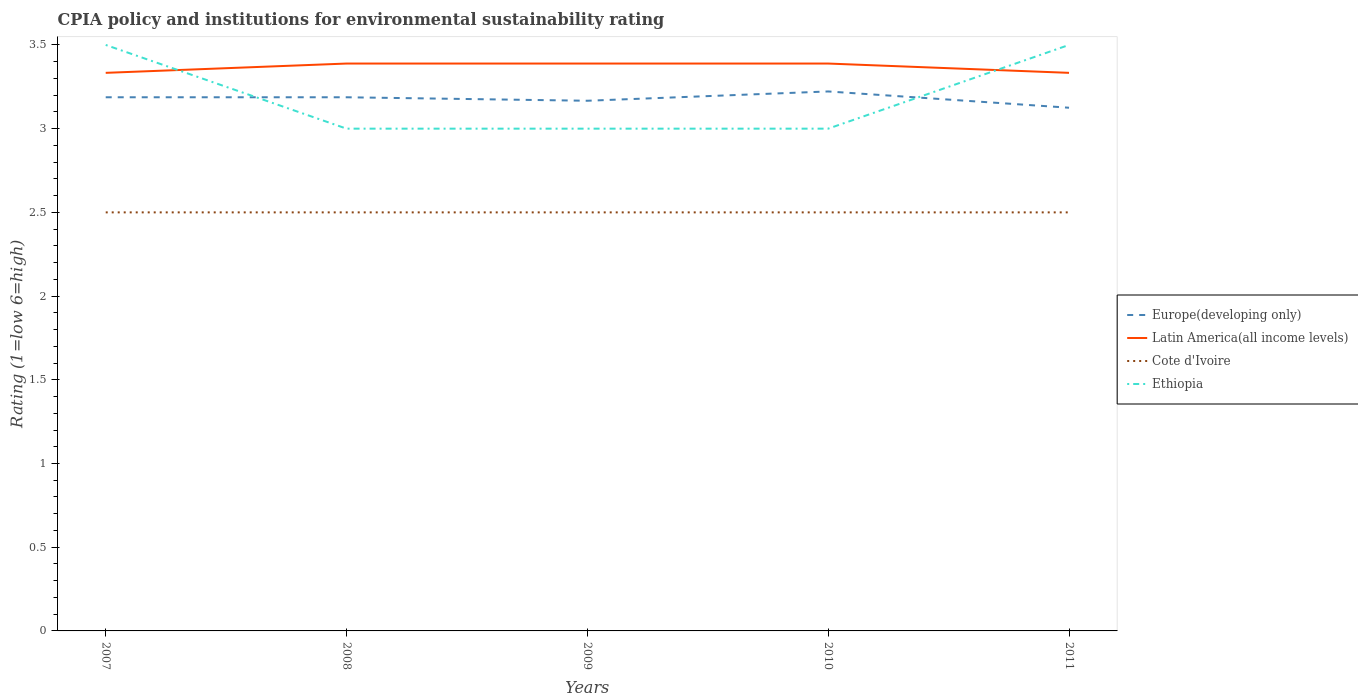How many different coloured lines are there?
Provide a short and direct response. 4. What is the total CPIA rating in Ethiopia in the graph?
Offer a terse response. 0. What is the difference between the highest and the second highest CPIA rating in Europe(developing only)?
Provide a short and direct response. 0.1. Are the values on the major ticks of Y-axis written in scientific E-notation?
Keep it short and to the point. No. Does the graph contain any zero values?
Your answer should be compact. No. Does the graph contain grids?
Make the answer very short. No. How many legend labels are there?
Keep it short and to the point. 4. How are the legend labels stacked?
Give a very brief answer. Vertical. What is the title of the graph?
Offer a terse response. CPIA policy and institutions for environmental sustainability rating. Does "Bahamas" appear as one of the legend labels in the graph?
Make the answer very short. No. What is the label or title of the X-axis?
Your answer should be compact. Years. What is the Rating (1=low 6=high) of Europe(developing only) in 2007?
Your response must be concise. 3.19. What is the Rating (1=low 6=high) of Latin America(all income levels) in 2007?
Offer a very short reply. 3.33. What is the Rating (1=low 6=high) in Ethiopia in 2007?
Ensure brevity in your answer.  3.5. What is the Rating (1=low 6=high) of Europe(developing only) in 2008?
Keep it short and to the point. 3.19. What is the Rating (1=low 6=high) of Latin America(all income levels) in 2008?
Give a very brief answer. 3.39. What is the Rating (1=low 6=high) of Cote d'Ivoire in 2008?
Keep it short and to the point. 2.5. What is the Rating (1=low 6=high) in Europe(developing only) in 2009?
Your answer should be very brief. 3.17. What is the Rating (1=low 6=high) in Latin America(all income levels) in 2009?
Provide a short and direct response. 3.39. What is the Rating (1=low 6=high) in Europe(developing only) in 2010?
Offer a very short reply. 3.22. What is the Rating (1=low 6=high) in Latin America(all income levels) in 2010?
Keep it short and to the point. 3.39. What is the Rating (1=low 6=high) of Cote d'Ivoire in 2010?
Offer a very short reply. 2.5. What is the Rating (1=low 6=high) of Europe(developing only) in 2011?
Your answer should be very brief. 3.12. What is the Rating (1=low 6=high) in Latin America(all income levels) in 2011?
Offer a very short reply. 3.33. What is the Rating (1=low 6=high) of Ethiopia in 2011?
Offer a terse response. 3.5. Across all years, what is the maximum Rating (1=low 6=high) in Europe(developing only)?
Your answer should be compact. 3.22. Across all years, what is the maximum Rating (1=low 6=high) in Latin America(all income levels)?
Your answer should be compact. 3.39. Across all years, what is the minimum Rating (1=low 6=high) of Europe(developing only)?
Offer a very short reply. 3.12. Across all years, what is the minimum Rating (1=low 6=high) of Latin America(all income levels)?
Your answer should be compact. 3.33. What is the total Rating (1=low 6=high) of Europe(developing only) in the graph?
Offer a terse response. 15.89. What is the total Rating (1=low 6=high) in Latin America(all income levels) in the graph?
Your answer should be very brief. 16.83. What is the difference between the Rating (1=low 6=high) of Europe(developing only) in 2007 and that in 2008?
Keep it short and to the point. 0. What is the difference between the Rating (1=low 6=high) in Latin America(all income levels) in 2007 and that in 2008?
Provide a short and direct response. -0.06. What is the difference between the Rating (1=low 6=high) of Europe(developing only) in 2007 and that in 2009?
Your answer should be compact. 0.02. What is the difference between the Rating (1=low 6=high) of Latin America(all income levels) in 2007 and that in 2009?
Your answer should be compact. -0.06. What is the difference between the Rating (1=low 6=high) in Cote d'Ivoire in 2007 and that in 2009?
Provide a short and direct response. 0. What is the difference between the Rating (1=low 6=high) in Ethiopia in 2007 and that in 2009?
Your answer should be compact. 0.5. What is the difference between the Rating (1=low 6=high) in Europe(developing only) in 2007 and that in 2010?
Make the answer very short. -0.03. What is the difference between the Rating (1=low 6=high) of Latin America(all income levels) in 2007 and that in 2010?
Provide a short and direct response. -0.06. What is the difference between the Rating (1=low 6=high) of Cote d'Ivoire in 2007 and that in 2010?
Your answer should be compact. 0. What is the difference between the Rating (1=low 6=high) in Europe(developing only) in 2007 and that in 2011?
Your answer should be very brief. 0.06. What is the difference between the Rating (1=low 6=high) in Latin America(all income levels) in 2007 and that in 2011?
Make the answer very short. 0. What is the difference between the Rating (1=low 6=high) in Cote d'Ivoire in 2007 and that in 2011?
Make the answer very short. 0. What is the difference between the Rating (1=low 6=high) in Ethiopia in 2007 and that in 2011?
Keep it short and to the point. 0. What is the difference between the Rating (1=low 6=high) of Europe(developing only) in 2008 and that in 2009?
Keep it short and to the point. 0.02. What is the difference between the Rating (1=low 6=high) of Latin America(all income levels) in 2008 and that in 2009?
Keep it short and to the point. 0. What is the difference between the Rating (1=low 6=high) of Europe(developing only) in 2008 and that in 2010?
Ensure brevity in your answer.  -0.03. What is the difference between the Rating (1=low 6=high) of Latin America(all income levels) in 2008 and that in 2010?
Your answer should be compact. 0. What is the difference between the Rating (1=low 6=high) of Cote d'Ivoire in 2008 and that in 2010?
Offer a terse response. 0. What is the difference between the Rating (1=low 6=high) of Europe(developing only) in 2008 and that in 2011?
Provide a short and direct response. 0.06. What is the difference between the Rating (1=low 6=high) of Latin America(all income levels) in 2008 and that in 2011?
Your response must be concise. 0.06. What is the difference between the Rating (1=low 6=high) in Cote d'Ivoire in 2008 and that in 2011?
Your response must be concise. 0. What is the difference between the Rating (1=low 6=high) of Europe(developing only) in 2009 and that in 2010?
Offer a terse response. -0.06. What is the difference between the Rating (1=low 6=high) in Ethiopia in 2009 and that in 2010?
Give a very brief answer. 0. What is the difference between the Rating (1=low 6=high) in Europe(developing only) in 2009 and that in 2011?
Provide a short and direct response. 0.04. What is the difference between the Rating (1=low 6=high) in Latin America(all income levels) in 2009 and that in 2011?
Keep it short and to the point. 0.06. What is the difference between the Rating (1=low 6=high) of Cote d'Ivoire in 2009 and that in 2011?
Provide a short and direct response. 0. What is the difference between the Rating (1=low 6=high) of Europe(developing only) in 2010 and that in 2011?
Offer a very short reply. 0.1. What is the difference between the Rating (1=low 6=high) in Latin America(all income levels) in 2010 and that in 2011?
Keep it short and to the point. 0.06. What is the difference between the Rating (1=low 6=high) of Cote d'Ivoire in 2010 and that in 2011?
Offer a terse response. 0. What is the difference between the Rating (1=low 6=high) in Ethiopia in 2010 and that in 2011?
Provide a short and direct response. -0.5. What is the difference between the Rating (1=low 6=high) in Europe(developing only) in 2007 and the Rating (1=low 6=high) in Latin America(all income levels) in 2008?
Your answer should be compact. -0.2. What is the difference between the Rating (1=low 6=high) of Europe(developing only) in 2007 and the Rating (1=low 6=high) of Cote d'Ivoire in 2008?
Give a very brief answer. 0.69. What is the difference between the Rating (1=low 6=high) in Europe(developing only) in 2007 and the Rating (1=low 6=high) in Ethiopia in 2008?
Keep it short and to the point. 0.19. What is the difference between the Rating (1=low 6=high) in Latin America(all income levels) in 2007 and the Rating (1=low 6=high) in Ethiopia in 2008?
Offer a very short reply. 0.33. What is the difference between the Rating (1=low 6=high) of Europe(developing only) in 2007 and the Rating (1=low 6=high) of Latin America(all income levels) in 2009?
Make the answer very short. -0.2. What is the difference between the Rating (1=low 6=high) of Europe(developing only) in 2007 and the Rating (1=low 6=high) of Cote d'Ivoire in 2009?
Provide a short and direct response. 0.69. What is the difference between the Rating (1=low 6=high) in Europe(developing only) in 2007 and the Rating (1=low 6=high) in Ethiopia in 2009?
Your response must be concise. 0.19. What is the difference between the Rating (1=low 6=high) in Europe(developing only) in 2007 and the Rating (1=low 6=high) in Latin America(all income levels) in 2010?
Give a very brief answer. -0.2. What is the difference between the Rating (1=low 6=high) of Europe(developing only) in 2007 and the Rating (1=low 6=high) of Cote d'Ivoire in 2010?
Ensure brevity in your answer.  0.69. What is the difference between the Rating (1=low 6=high) of Europe(developing only) in 2007 and the Rating (1=low 6=high) of Ethiopia in 2010?
Provide a short and direct response. 0.19. What is the difference between the Rating (1=low 6=high) of Latin America(all income levels) in 2007 and the Rating (1=low 6=high) of Cote d'Ivoire in 2010?
Your response must be concise. 0.83. What is the difference between the Rating (1=low 6=high) of Europe(developing only) in 2007 and the Rating (1=low 6=high) of Latin America(all income levels) in 2011?
Offer a terse response. -0.15. What is the difference between the Rating (1=low 6=high) of Europe(developing only) in 2007 and the Rating (1=low 6=high) of Cote d'Ivoire in 2011?
Ensure brevity in your answer.  0.69. What is the difference between the Rating (1=low 6=high) of Europe(developing only) in 2007 and the Rating (1=low 6=high) of Ethiopia in 2011?
Provide a short and direct response. -0.31. What is the difference between the Rating (1=low 6=high) in Cote d'Ivoire in 2007 and the Rating (1=low 6=high) in Ethiopia in 2011?
Your response must be concise. -1. What is the difference between the Rating (1=low 6=high) in Europe(developing only) in 2008 and the Rating (1=low 6=high) in Latin America(all income levels) in 2009?
Keep it short and to the point. -0.2. What is the difference between the Rating (1=low 6=high) of Europe(developing only) in 2008 and the Rating (1=low 6=high) of Cote d'Ivoire in 2009?
Provide a succinct answer. 0.69. What is the difference between the Rating (1=low 6=high) in Europe(developing only) in 2008 and the Rating (1=low 6=high) in Ethiopia in 2009?
Offer a terse response. 0.19. What is the difference between the Rating (1=low 6=high) of Latin America(all income levels) in 2008 and the Rating (1=low 6=high) of Ethiopia in 2009?
Give a very brief answer. 0.39. What is the difference between the Rating (1=low 6=high) of Europe(developing only) in 2008 and the Rating (1=low 6=high) of Latin America(all income levels) in 2010?
Your response must be concise. -0.2. What is the difference between the Rating (1=low 6=high) of Europe(developing only) in 2008 and the Rating (1=low 6=high) of Cote d'Ivoire in 2010?
Keep it short and to the point. 0.69. What is the difference between the Rating (1=low 6=high) of Europe(developing only) in 2008 and the Rating (1=low 6=high) of Ethiopia in 2010?
Your answer should be very brief. 0.19. What is the difference between the Rating (1=low 6=high) in Latin America(all income levels) in 2008 and the Rating (1=low 6=high) in Cote d'Ivoire in 2010?
Keep it short and to the point. 0.89. What is the difference between the Rating (1=low 6=high) of Latin America(all income levels) in 2008 and the Rating (1=low 6=high) of Ethiopia in 2010?
Offer a terse response. 0.39. What is the difference between the Rating (1=low 6=high) in Cote d'Ivoire in 2008 and the Rating (1=low 6=high) in Ethiopia in 2010?
Offer a terse response. -0.5. What is the difference between the Rating (1=low 6=high) of Europe(developing only) in 2008 and the Rating (1=low 6=high) of Latin America(all income levels) in 2011?
Your response must be concise. -0.15. What is the difference between the Rating (1=low 6=high) in Europe(developing only) in 2008 and the Rating (1=low 6=high) in Cote d'Ivoire in 2011?
Make the answer very short. 0.69. What is the difference between the Rating (1=low 6=high) in Europe(developing only) in 2008 and the Rating (1=low 6=high) in Ethiopia in 2011?
Offer a terse response. -0.31. What is the difference between the Rating (1=low 6=high) in Latin America(all income levels) in 2008 and the Rating (1=low 6=high) in Cote d'Ivoire in 2011?
Keep it short and to the point. 0.89. What is the difference between the Rating (1=low 6=high) in Latin America(all income levels) in 2008 and the Rating (1=low 6=high) in Ethiopia in 2011?
Give a very brief answer. -0.11. What is the difference between the Rating (1=low 6=high) in Europe(developing only) in 2009 and the Rating (1=low 6=high) in Latin America(all income levels) in 2010?
Offer a terse response. -0.22. What is the difference between the Rating (1=low 6=high) in Europe(developing only) in 2009 and the Rating (1=low 6=high) in Cote d'Ivoire in 2010?
Keep it short and to the point. 0.67. What is the difference between the Rating (1=low 6=high) of Latin America(all income levels) in 2009 and the Rating (1=low 6=high) of Ethiopia in 2010?
Make the answer very short. 0.39. What is the difference between the Rating (1=low 6=high) of Cote d'Ivoire in 2009 and the Rating (1=low 6=high) of Ethiopia in 2010?
Provide a succinct answer. -0.5. What is the difference between the Rating (1=low 6=high) in Latin America(all income levels) in 2009 and the Rating (1=low 6=high) in Ethiopia in 2011?
Ensure brevity in your answer.  -0.11. What is the difference between the Rating (1=low 6=high) in Cote d'Ivoire in 2009 and the Rating (1=low 6=high) in Ethiopia in 2011?
Offer a very short reply. -1. What is the difference between the Rating (1=low 6=high) in Europe(developing only) in 2010 and the Rating (1=low 6=high) in Latin America(all income levels) in 2011?
Your answer should be compact. -0.11. What is the difference between the Rating (1=low 6=high) of Europe(developing only) in 2010 and the Rating (1=low 6=high) of Cote d'Ivoire in 2011?
Your answer should be very brief. 0.72. What is the difference between the Rating (1=low 6=high) of Europe(developing only) in 2010 and the Rating (1=low 6=high) of Ethiopia in 2011?
Your response must be concise. -0.28. What is the difference between the Rating (1=low 6=high) in Latin America(all income levels) in 2010 and the Rating (1=low 6=high) in Ethiopia in 2011?
Offer a terse response. -0.11. What is the average Rating (1=low 6=high) in Europe(developing only) per year?
Make the answer very short. 3.18. What is the average Rating (1=low 6=high) in Latin America(all income levels) per year?
Keep it short and to the point. 3.37. What is the average Rating (1=low 6=high) in Cote d'Ivoire per year?
Make the answer very short. 2.5. What is the average Rating (1=low 6=high) in Ethiopia per year?
Ensure brevity in your answer.  3.2. In the year 2007, what is the difference between the Rating (1=low 6=high) in Europe(developing only) and Rating (1=low 6=high) in Latin America(all income levels)?
Offer a very short reply. -0.15. In the year 2007, what is the difference between the Rating (1=low 6=high) in Europe(developing only) and Rating (1=low 6=high) in Cote d'Ivoire?
Ensure brevity in your answer.  0.69. In the year 2007, what is the difference between the Rating (1=low 6=high) in Europe(developing only) and Rating (1=low 6=high) in Ethiopia?
Keep it short and to the point. -0.31. In the year 2007, what is the difference between the Rating (1=low 6=high) in Cote d'Ivoire and Rating (1=low 6=high) in Ethiopia?
Offer a very short reply. -1. In the year 2008, what is the difference between the Rating (1=low 6=high) of Europe(developing only) and Rating (1=low 6=high) of Latin America(all income levels)?
Provide a succinct answer. -0.2. In the year 2008, what is the difference between the Rating (1=low 6=high) in Europe(developing only) and Rating (1=low 6=high) in Cote d'Ivoire?
Offer a terse response. 0.69. In the year 2008, what is the difference between the Rating (1=low 6=high) of Europe(developing only) and Rating (1=low 6=high) of Ethiopia?
Make the answer very short. 0.19. In the year 2008, what is the difference between the Rating (1=low 6=high) in Latin America(all income levels) and Rating (1=low 6=high) in Cote d'Ivoire?
Your answer should be very brief. 0.89. In the year 2008, what is the difference between the Rating (1=low 6=high) in Latin America(all income levels) and Rating (1=low 6=high) in Ethiopia?
Keep it short and to the point. 0.39. In the year 2009, what is the difference between the Rating (1=low 6=high) in Europe(developing only) and Rating (1=low 6=high) in Latin America(all income levels)?
Provide a succinct answer. -0.22. In the year 2009, what is the difference between the Rating (1=low 6=high) in Europe(developing only) and Rating (1=low 6=high) in Cote d'Ivoire?
Your answer should be compact. 0.67. In the year 2009, what is the difference between the Rating (1=low 6=high) of Latin America(all income levels) and Rating (1=low 6=high) of Ethiopia?
Your response must be concise. 0.39. In the year 2009, what is the difference between the Rating (1=low 6=high) in Cote d'Ivoire and Rating (1=low 6=high) in Ethiopia?
Make the answer very short. -0.5. In the year 2010, what is the difference between the Rating (1=low 6=high) in Europe(developing only) and Rating (1=low 6=high) in Cote d'Ivoire?
Your response must be concise. 0.72. In the year 2010, what is the difference between the Rating (1=low 6=high) in Europe(developing only) and Rating (1=low 6=high) in Ethiopia?
Your response must be concise. 0.22. In the year 2010, what is the difference between the Rating (1=low 6=high) of Latin America(all income levels) and Rating (1=low 6=high) of Cote d'Ivoire?
Your answer should be very brief. 0.89. In the year 2010, what is the difference between the Rating (1=low 6=high) in Latin America(all income levels) and Rating (1=low 6=high) in Ethiopia?
Your answer should be compact. 0.39. In the year 2010, what is the difference between the Rating (1=low 6=high) in Cote d'Ivoire and Rating (1=low 6=high) in Ethiopia?
Keep it short and to the point. -0.5. In the year 2011, what is the difference between the Rating (1=low 6=high) of Europe(developing only) and Rating (1=low 6=high) of Latin America(all income levels)?
Offer a terse response. -0.21. In the year 2011, what is the difference between the Rating (1=low 6=high) in Europe(developing only) and Rating (1=low 6=high) in Ethiopia?
Provide a succinct answer. -0.38. In the year 2011, what is the difference between the Rating (1=low 6=high) in Latin America(all income levels) and Rating (1=low 6=high) in Cote d'Ivoire?
Your response must be concise. 0.83. What is the ratio of the Rating (1=low 6=high) in Latin America(all income levels) in 2007 to that in 2008?
Your answer should be compact. 0.98. What is the ratio of the Rating (1=low 6=high) of Ethiopia in 2007 to that in 2008?
Provide a short and direct response. 1.17. What is the ratio of the Rating (1=low 6=high) in Europe(developing only) in 2007 to that in 2009?
Provide a short and direct response. 1.01. What is the ratio of the Rating (1=low 6=high) of Latin America(all income levels) in 2007 to that in 2009?
Give a very brief answer. 0.98. What is the ratio of the Rating (1=low 6=high) in Ethiopia in 2007 to that in 2009?
Give a very brief answer. 1.17. What is the ratio of the Rating (1=low 6=high) of Europe(developing only) in 2007 to that in 2010?
Keep it short and to the point. 0.99. What is the ratio of the Rating (1=low 6=high) in Latin America(all income levels) in 2007 to that in 2010?
Provide a short and direct response. 0.98. What is the ratio of the Rating (1=low 6=high) in Cote d'Ivoire in 2007 to that in 2010?
Ensure brevity in your answer.  1. What is the ratio of the Rating (1=low 6=high) in Europe(developing only) in 2007 to that in 2011?
Your answer should be compact. 1.02. What is the ratio of the Rating (1=low 6=high) of Latin America(all income levels) in 2007 to that in 2011?
Offer a terse response. 1. What is the ratio of the Rating (1=low 6=high) in Europe(developing only) in 2008 to that in 2009?
Provide a succinct answer. 1.01. What is the ratio of the Rating (1=low 6=high) of Latin America(all income levels) in 2008 to that in 2009?
Provide a succinct answer. 1. What is the ratio of the Rating (1=low 6=high) of Cote d'Ivoire in 2008 to that in 2009?
Ensure brevity in your answer.  1. What is the ratio of the Rating (1=low 6=high) in Ethiopia in 2008 to that in 2009?
Give a very brief answer. 1. What is the ratio of the Rating (1=low 6=high) in Cote d'Ivoire in 2008 to that in 2010?
Offer a very short reply. 1. What is the ratio of the Rating (1=low 6=high) of Europe(developing only) in 2008 to that in 2011?
Ensure brevity in your answer.  1.02. What is the ratio of the Rating (1=low 6=high) of Latin America(all income levels) in 2008 to that in 2011?
Offer a very short reply. 1.02. What is the ratio of the Rating (1=low 6=high) of Cote d'Ivoire in 2008 to that in 2011?
Provide a succinct answer. 1. What is the ratio of the Rating (1=low 6=high) of Ethiopia in 2008 to that in 2011?
Keep it short and to the point. 0.86. What is the ratio of the Rating (1=low 6=high) of Europe(developing only) in 2009 to that in 2010?
Keep it short and to the point. 0.98. What is the ratio of the Rating (1=low 6=high) of Latin America(all income levels) in 2009 to that in 2010?
Keep it short and to the point. 1. What is the ratio of the Rating (1=low 6=high) in Ethiopia in 2009 to that in 2010?
Ensure brevity in your answer.  1. What is the ratio of the Rating (1=low 6=high) of Europe(developing only) in 2009 to that in 2011?
Give a very brief answer. 1.01. What is the ratio of the Rating (1=low 6=high) of Latin America(all income levels) in 2009 to that in 2011?
Offer a terse response. 1.02. What is the ratio of the Rating (1=low 6=high) of Europe(developing only) in 2010 to that in 2011?
Provide a succinct answer. 1.03. What is the ratio of the Rating (1=low 6=high) of Latin America(all income levels) in 2010 to that in 2011?
Your answer should be very brief. 1.02. What is the ratio of the Rating (1=low 6=high) of Cote d'Ivoire in 2010 to that in 2011?
Provide a succinct answer. 1. What is the difference between the highest and the second highest Rating (1=low 6=high) of Europe(developing only)?
Provide a succinct answer. 0.03. What is the difference between the highest and the second highest Rating (1=low 6=high) in Ethiopia?
Keep it short and to the point. 0. What is the difference between the highest and the lowest Rating (1=low 6=high) in Europe(developing only)?
Keep it short and to the point. 0.1. What is the difference between the highest and the lowest Rating (1=low 6=high) of Latin America(all income levels)?
Your answer should be very brief. 0.06. What is the difference between the highest and the lowest Rating (1=low 6=high) in Ethiopia?
Keep it short and to the point. 0.5. 